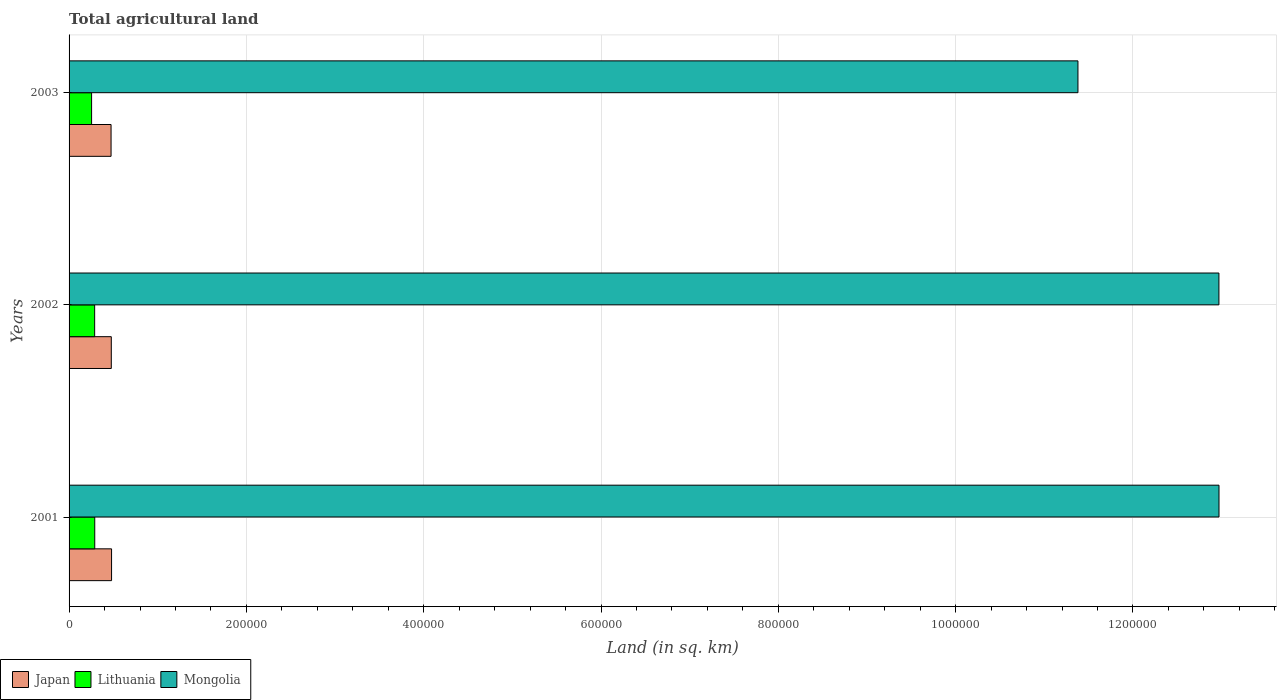How many groups of bars are there?
Offer a terse response. 3. Are the number of bars on each tick of the Y-axis equal?
Your answer should be compact. Yes. What is the label of the 2nd group of bars from the top?
Offer a terse response. 2002. What is the total agricultural land in Japan in 2003?
Provide a succinct answer. 4.74e+04. Across all years, what is the maximum total agricultural land in Japan?
Your response must be concise. 4.79e+04. Across all years, what is the minimum total agricultural land in Mongolia?
Your answer should be very brief. 1.14e+06. In which year was the total agricultural land in Mongolia maximum?
Your answer should be compact. 2001. What is the total total agricultural land in Lithuania in the graph?
Offer a very short reply. 8.32e+04. What is the difference between the total agricultural land in Mongolia in 2001 and that in 2002?
Ensure brevity in your answer.  90. What is the difference between the total agricultural land in Mongolia in 2001 and the total agricultural land in Lithuania in 2002?
Provide a short and direct response. 1.27e+06. What is the average total agricultural land in Mongolia per year?
Provide a short and direct response. 1.24e+06. In the year 2001, what is the difference between the total agricultural land in Mongolia and total agricultural land in Japan?
Ensure brevity in your answer.  1.25e+06. In how many years, is the total agricultural land in Lithuania greater than 680000 sq.km?
Provide a succinct answer. 0. What is the ratio of the total agricultural land in Japan in 2001 to that in 2003?
Keep it short and to the point. 1.01. Is the total agricultural land in Mongolia in 2001 less than that in 2002?
Provide a succinct answer. No. What is the difference between the highest and the lowest total agricultural land in Japan?
Make the answer very short. 570. In how many years, is the total agricultural land in Lithuania greater than the average total agricultural land in Lithuania taken over all years?
Offer a terse response. 2. What does the 2nd bar from the bottom in 2001 represents?
Provide a short and direct response. Lithuania. How many years are there in the graph?
Give a very brief answer. 3. What is the difference between two consecutive major ticks on the X-axis?
Your response must be concise. 2.00e+05. Are the values on the major ticks of X-axis written in scientific E-notation?
Provide a succinct answer. No. Does the graph contain grids?
Ensure brevity in your answer.  Yes. What is the title of the graph?
Keep it short and to the point. Total agricultural land. Does "Low income" appear as one of the legend labels in the graph?
Offer a terse response. No. What is the label or title of the X-axis?
Ensure brevity in your answer.  Land (in sq. km). What is the label or title of the Y-axis?
Provide a succinct answer. Years. What is the Land (in sq. km) in Japan in 2001?
Make the answer very short. 4.79e+04. What is the Land (in sq. km) of Lithuania in 2001?
Offer a terse response. 2.90e+04. What is the Land (in sq. km) of Mongolia in 2001?
Make the answer very short. 1.30e+06. What is the Land (in sq. km) of Japan in 2002?
Your answer should be compact. 4.76e+04. What is the Land (in sq. km) in Lithuania in 2002?
Your answer should be compact. 2.88e+04. What is the Land (in sq. km) in Mongolia in 2002?
Offer a very short reply. 1.30e+06. What is the Land (in sq. km) in Japan in 2003?
Your answer should be very brief. 4.74e+04. What is the Land (in sq. km) in Lithuania in 2003?
Provide a short and direct response. 2.54e+04. What is the Land (in sq. km) of Mongolia in 2003?
Provide a short and direct response. 1.14e+06. Across all years, what is the maximum Land (in sq. km) of Japan?
Your response must be concise. 4.79e+04. Across all years, what is the maximum Land (in sq. km) in Lithuania?
Ensure brevity in your answer.  2.90e+04. Across all years, what is the maximum Land (in sq. km) in Mongolia?
Provide a short and direct response. 1.30e+06. Across all years, what is the minimum Land (in sq. km) of Japan?
Give a very brief answer. 4.74e+04. Across all years, what is the minimum Land (in sq. km) of Lithuania?
Provide a succinct answer. 2.54e+04. Across all years, what is the minimum Land (in sq. km) in Mongolia?
Your answer should be very brief. 1.14e+06. What is the total Land (in sq. km) in Japan in the graph?
Your response must be concise. 1.43e+05. What is the total Land (in sq. km) in Lithuania in the graph?
Offer a terse response. 8.32e+04. What is the total Land (in sq. km) in Mongolia in the graph?
Give a very brief answer. 3.73e+06. What is the difference between the Land (in sq. km) of Japan in 2001 and that in 2002?
Give a very brief answer. 300. What is the difference between the Land (in sq. km) in Lithuania in 2001 and that in 2002?
Make the answer very short. 110. What is the difference between the Land (in sq. km) of Mongolia in 2001 and that in 2002?
Provide a succinct answer. 90. What is the difference between the Land (in sq. km) of Japan in 2001 and that in 2003?
Provide a succinct answer. 570. What is the difference between the Land (in sq. km) in Lithuania in 2001 and that in 2003?
Give a very brief answer. 3550. What is the difference between the Land (in sq. km) in Mongolia in 2001 and that in 2003?
Your answer should be compact. 1.59e+05. What is the difference between the Land (in sq. km) in Japan in 2002 and that in 2003?
Keep it short and to the point. 270. What is the difference between the Land (in sq. km) of Lithuania in 2002 and that in 2003?
Your answer should be compact. 3440. What is the difference between the Land (in sq. km) of Mongolia in 2002 and that in 2003?
Provide a short and direct response. 1.59e+05. What is the difference between the Land (in sq. km) of Japan in 2001 and the Land (in sq. km) of Lithuania in 2002?
Make the answer very short. 1.91e+04. What is the difference between the Land (in sq. km) of Japan in 2001 and the Land (in sq. km) of Mongolia in 2002?
Make the answer very short. -1.25e+06. What is the difference between the Land (in sq. km) in Lithuania in 2001 and the Land (in sq. km) in Mongolia in 2002?
Provide a succinct answer. -1.27e+06. What is the difference between the Land (in sq. km) of Japan in 2001 and the Land (in sq. km) of Lithuania in 2003?
Your answer should be very brief. 2.25e+04. What is the difference between the Land (in sq. km) of Japan in 2001 and the Land (in sq. km) of Mongolia in 2003?
Provide a succinct answer. -1.09e+06. What is the difference between the Land (in sq. km) in Lithuania in 2001 and the Land (in sq. km) in Mongolia in 2003?
Provide a succinct answer. -1.11e+06. What is the difference between the Land (in sq. km) of Japan in 2002 and the Land (in sq. km) of Lithuania in 2003?
Your response must be concise. 2.22e+04. What is the difference between the Land (in sq. km) of Japan in 2002 and the Land (in sq. km) of Mongolia in 2003?
Keep it short and to the point. -1.09e+06. What is the difference between the Land (in sq. km) in Lithuania in 2002 and the Land (in sq. km) in Mongolia in 2003?
Give a very brief answer. -1.11e+06. What is the average Land (in sq. km) of Japan per year?
Your answer should be very brief. 4.76e+04. What is the average Land (in sq. km) of Lithuania per year?
Offer a terse response. 2.77e+04. What is the average Land (in sq. km) of Mongolia per year?
Keep it short and to the point. 1.24e+06. In the year 2001, what is the difference between the Land (in sq. km) of Japan and Land (in sq. km) of Lithuania?
Ensure brevity in your answer.  1.90e+04. In the year 2001, what is the difference between the Land (in sq. km) of Japan and Land (in sq. km) of Mongolia?
Offer a very short reply. -1.25e+06. In the year 2001, what is the difference between the Land (in sq. km) of Lithuania and Land (in sq. km) of Mongolia?
Give a very brief answer. -1.27e+06. In the year 2002, what is the difference between the Land (in sq. km) of Japan and Land (in sq. km) of Lithuania?
Provide a succinct answer. 1.88e+04. In the year 2002, what is the difference between the Land (in sq. km) of Japan and Land (in sq. km) of Mongolia?
Provide a succinct answer. -1.25e+06. In the year 2002, what is the difference between the Land (in sq. km) in Lithuania and Land (in sq. km) in Mongolia?
Give a very brief answer. -1.27e+06. In the year 2003, what is the difference between the Land (in sq. km) of Japan and Land (in sq. km) of Lithuania?
Offer a terse response. 2.20e+04. In the year 2003, what is the difference between the Land (in sq. km) in Japan and Land (in sq. km) in Mongolia?
Your answer should be very brief. -1.09e+06. In the year 2003, what is the difference between the Land (in sq. km) of Lithuania and Land (in sq. km) of Mongolia?
Keep it short and to the point. -1.11e+06. What is the ratio of the Land (in sq. km) of Japan in 2001 to that in 2002?
Provide a short and direct response. 1.01. What is the ratio of the Land (in sq. km) of Lithuania in 2001 to that in 2002?
Ensure brevity in your answer.  1. What is the ratio of the Land (in sq. km) of Mongolia in 2001 to that in 2002?
Make the answer very short. 1. What is the ratio of the Land (in sq. km) in Japan in 2001 to that in 2003?
Ensure brevity in your answer.  1.01. What is the ratio of the Land (in sq. km) in Lithuania in 2001 to that in 2003?
Provide a short and direct response. 1.14. What is the ratio of the Land (in sq. km) in Mongolia in 2001 to that in 2003?
Your answer should be very brief. 1.14. What is the ratio of the Land (in sq. km) in Japan in 2002 to that in 2003?
Provide a short and direct response. 1.01. What is the ratio of the Land (in sq. km) of Lithuania in 2002 to that in 2003?
Ensure brevity in your answer.  1.14. What is the ratio of the Land (in sq. km) in Mongolia in 2002 to that in 2003?
Offer a very short reply. 1.14. What is the difference between the highest and the second highest Land (in sq. km) of Japan?
Provide a succinct answer. 300. What is the difference between the highest and the second highest Land (in sq. km) of Lithuania?
Your response must be concise. 110. What is the difference between the highest and the lowest Land (in sq. km) in Japan?
Give a very brief answer. 570. What is the difference between the highest and the lowest Land (in sq. km) of Lithuania?
Offer a terse response. 3550. What is the difference between the highest and the lowest Land (in sq. km) in Mongolia?
Offer a very short reply. 1.59e+05. 